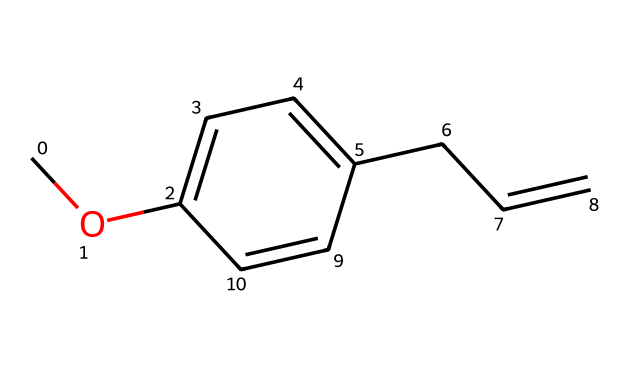What is the molecular formula of estragole? From the SMILES representation, we can identify the types and numbers of atoms present. The formula can be deduced as follows: there are 10 carbons (C), 12 hydrogens (H), and 1 oxygen (O), leading to the molecular formula C10H12O.
Answer: C10H12O How many rings are present in the structure? Observing the given SMILES, we can look for any ring indications. There are no numerical indicators indicating a cycle; thus, there are no rings in the structure of estragole.
Answer: 0 What type of bonding is present between the carbon atoms? By examining the structure, we can see single bonds and a double bond (the CC=C section). The majority of the carbon atoms are connected through single bonds, while one connection features a double bond, indicating it is mainly composed of sigma bonds, with one pi bond present in the double bond.
Answer: single and double bonds What role does the methoxy group (-O-CH3) play in the molecule? The methoxy group is responsible for the ether designation of this compound. It contributes to its solubility properties and influences its reactivity due to the presence of the oxygen atom bonded to the carbon chain.
Answer: ether designation What is the functional group in estragole? The functional group in this ether compound is the methoxy group (-O-CH3), which is characteristic of ethers. It also plays a role in the molecule’s behavior, especially concerning its chemical reactivity.
Answer: methoxy group What is the unsaturation degree of estragole? The degree of unsaturation can be calculated by analyzing the number of rings and pi bonds. The SMILES indicates one double bond which contributes to the degree of unsaturation, thus the molecule has one degree of unsaturation.
Answer: 1 